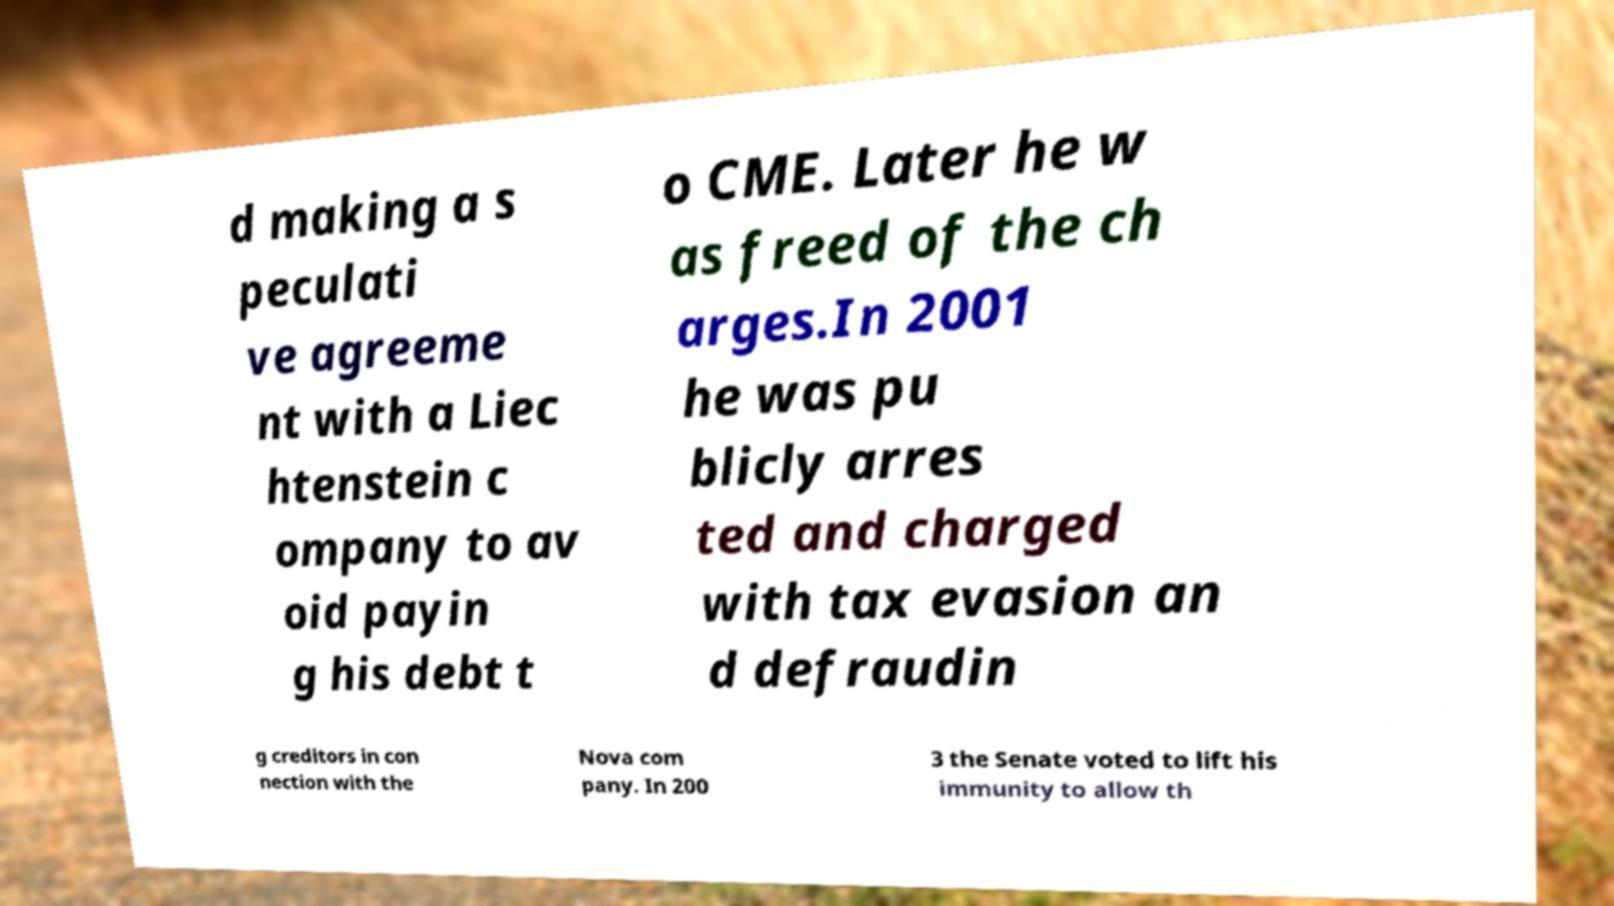For documentation purposes, I need the text within this image transcribed. Could you provide that? d making a s peculati ve agreeme nt with a Liec htenstein c ompany to av oid payin g his debt t o CME. Later he w as freed of the ch arges.In 2001 he was pu blicly arres ted and charged with tax evasion an d defraudin g creditors in con nection with the Nova com pany. In 200 3 the Senate voted to lift his immunity to allow th 